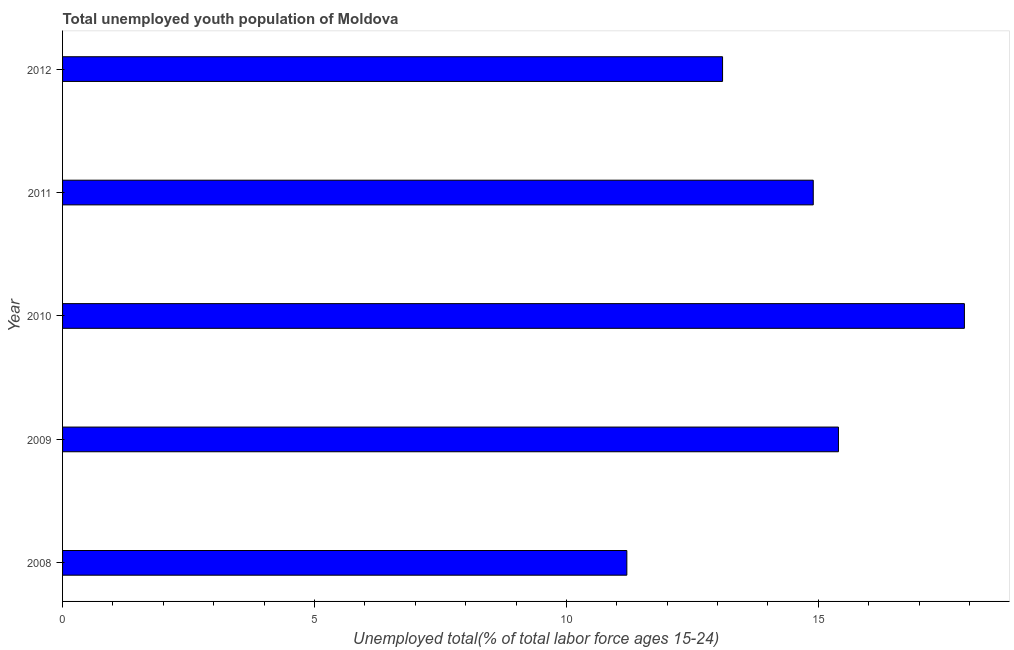Does the graph contain any zero values?
Your answer should be compact. No. Does the graph contain grids?
Provide a succinct answer. No. What is the title of the graph?
Give a very brief answer. Total unemployed youth population of Moldova. What is the label or title of the X-axis?
Offer a very short reply. Unemployed total(% of total labor force ages 15-24). What is the label or title of the Y-axis?
Your response must be concise. Year. What is the unemployed youth in 2008?
Your response must be concise. 11.2. Across all years, what is the maximum unemployed youth?
Keep it short and to the point. 17.9. Across all years, what is the minimum unemployed youth?
Make the answer very short. 11.2. In which year was the unemployed youth maximum?
Provide a short and direct response. 2010. In which year was the unemployed youth minimum?
Make the answer very short. 2008. What is the sum of the unemployed youth?
Make the answer very short. 72.5. What is the median unemployed youth?
Offer a very short reply. 14.9. In how many years, is the unemployed youth greater than 13 %?
Keep it short and to the point. 4. Do a majority of the years between 2011 and 2012 (inclusive) have unemployed youth greater than 13 %?
Offer a terse response. Yes. What is the ratio of the unemployed youth in 2009 to that in 2010?
Ensure brevity in your answer.  0.86. Is the sum of the unemployed youth in 2009 and 2012 greater than the maximum unemployed youth across all years?
Keep it short and to the point. Yes. In how many years, is the unemployed youth greater than the average unemployed youth taken over all years?
Your answer should be compact. 3. Are all the bars in the graph horizontal?
Provide a succinct answer. Yes. What is the difference between two consecutive major ticks on the X-axis?
Make the answer very short. 5. Are the values on the major ticks of X-axis written in scientific E-notation?
Keep it short and to the point. No. What is the Unemployed total(% of total labor force ages 15-24) in 2008?
Your response must be concise. 11.2. What is the Unemployed total(% of total labor force ages 15-24) in 2009?
Your answer should be very brief. 15.4. What is the Unemployed total(% of total labor force ages 15-24) in 2010?
Keep it short and to the point. 17.9. What is the Unemployed total(% of total labor force ages 15-24) of 2011?
Make the answer very short. 14.9. What is the Unemployed total(% of total labor force ages 15-24) in 2012?
Your answer should be compact. 13.1. What is the difference between the Unemployed total(% of total labor force ages 15-24) in 2008 and 2009?
Offer a terse response. -4.2. What is the difference between the Unemployed total(% of total labor force ages 15-24) in 2008 and 2011?
Keep it short and to the point. -3.7. What is the difference between the Unemployed total(% of total labor force ages 15-24) in 2009 and 2011?
Offer a very short reply. 0.5. What is the ratio of the Unemployed total(% of total labor force ages 15-24) in 2008 to that in 2009?
Give a very brief answer. 0.73. What is the ratio of the Unemployed total(% of total labor force ages 15-24) in 2008 to that in 2010?
Keep it short and to the point. 0.63. What is the ratio of the Unemployed total(% of total labor force ages 15-24) in 2008 to that in 2011?
Offer a very short reply. 0.75. What is the ratio of the Unemployed total(% of total labor force ages 15-24) in 2008 to that in 2012?
Your answer should be very brief. 0.85. What is the ratio of the Unemployed total(% of total labor force ages 15-24) in 2009 to that in 2010?
Offer a very short reply. 0.86. What is the ratio of the Unemployed total(% of total labor force ages 15-24) in 2009 to that in 2011?
Offer a terse response. 1.03. What is the ratio of the Unemployed total(% of total labor force ages 15-24) in 2009 to that in 2012?
Your answer should be very brief. 1.18. What is the ratio of the Unemployed total(% of total labor force ages 15-24) in 2010 to that in 2011?
Your answer should be compact. 1.2. What is the ratio of the Unemployed total(% of total labor force ages 15-24) in 2010 to that in 2012?
Provide a succinct answer. 1.37. What is the ratio of the Unemployed total(% of total labor force ages 15-24) in 2011 to that in 2012?
Give a very brief answer. 1.14. 